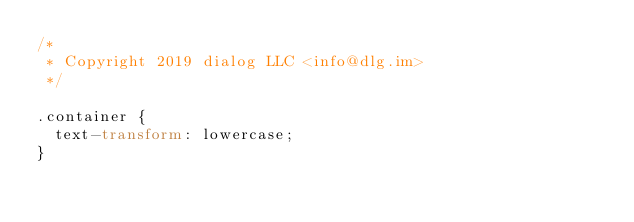<code> <loc_0><loc_0><loc_500><loc_500><_CSS_>/*
 * Copyright 2019 dialog LLC <info@dlg.im>
 */

.container {
  text-transform: lowercase;
}
</code> 